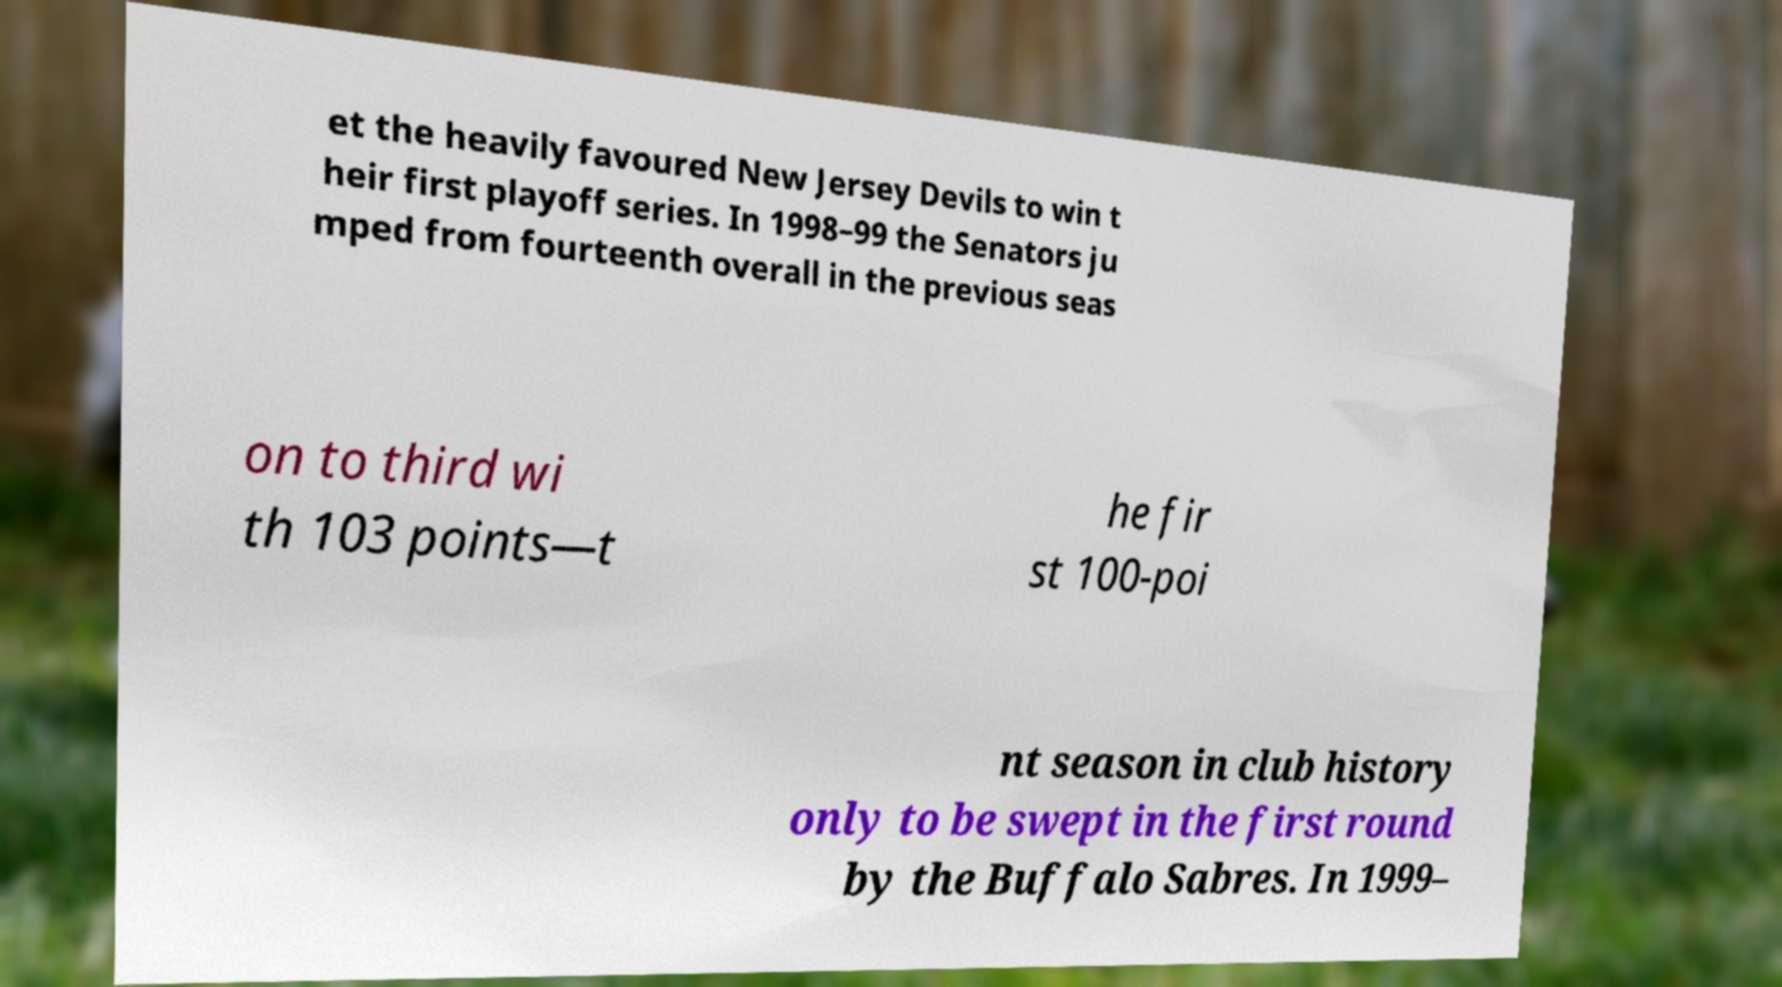Please identify and transcribe the text found in this image. et the heavily favoured New Jersey Devils to win t heir first playoff series. In 1998–99 the Senators ju mped from fourteenth overall in the previous seas on to third wi th 103 points—t he fir st 100-poi nt season in club history only to be swept in the first round by the Buffalo Sabres. In 1999– 